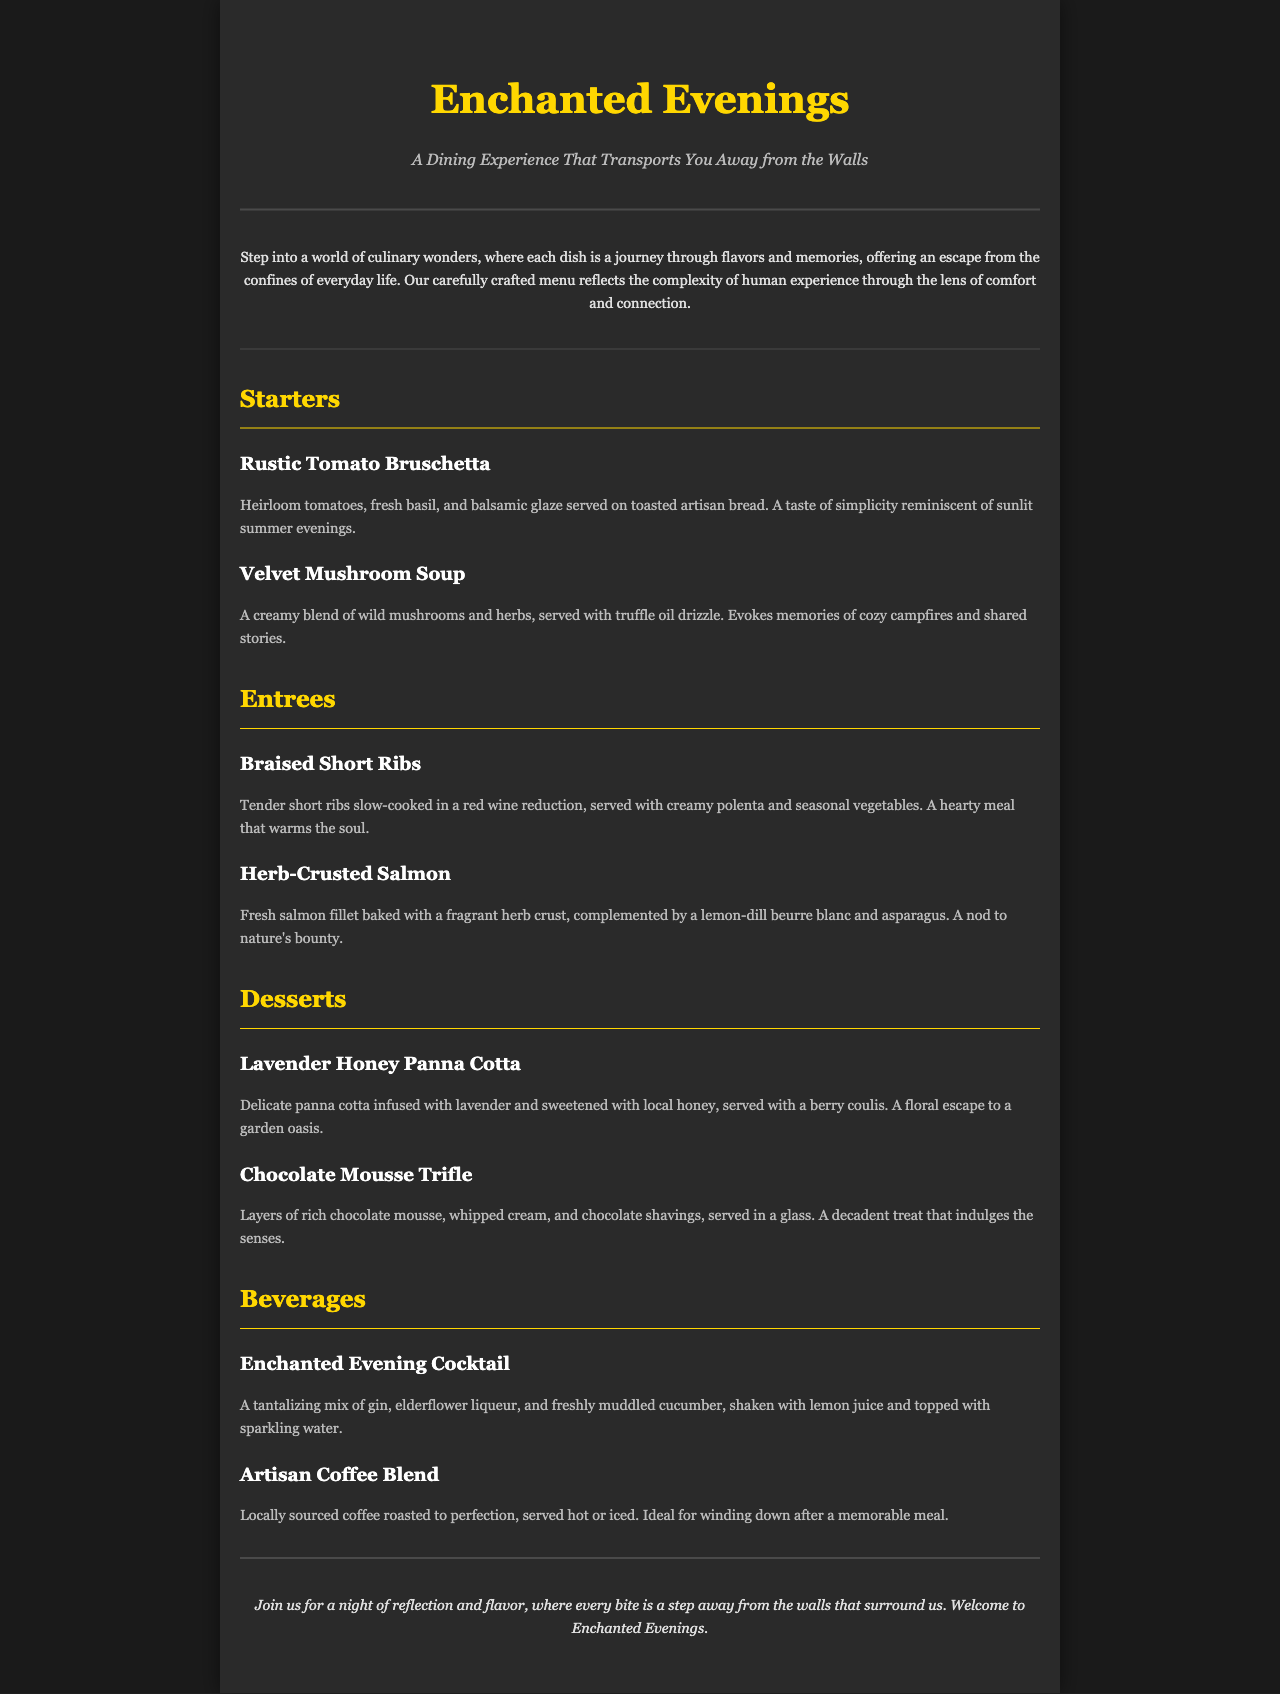what is the name of the dining experience? The title of the dining experience is mentioned at the top of the document as "Enchanted Evenings."
Answer: Enchanted Evenings how many sections are in the menu? The menu contains four sections: Starters, Entrees, Desserts, and Beverages.
Answer: Four what is the first starter listed on the menu? The first starter listed in the Starters section is "Rustic Tomato Bruschetta."
Answer: Rustic Tomato Bruschetta which dessert includes lavender? The dessert that includes lavender is "Lavender Honey Panna Cotta."
Answer: Lavender Honey Panna Cotta what kind of fish is served in the entrees? The type of fish served in the entrees is salmon, specifically "Herb-Crusted Salmon."
Answer: Salmon what flavor profile does the Enchanted Evening Cocktail feature? The cocktail features a mix of gin, elderflower liqueur, and cucumber, with a refreshing aspect from the lemon juice and sparkling water.
Answer: Gin, elderflower, cucumber which beverage is ideal for winding down after a meal? The beverage described as ideal for winding down after a meal is "Artisan Coffee Blend."
Answer: Artisan Coffee Blend which section includes the Chocolate Mousse Trifle? The Chocolate Mousse Trifle is included in the Desserts section of the menu.
Answer: Desserts what is the primary theme of the introduction? The introduction emphasizes stepping into a world of culinary wonders and escaping everyday life.
Answer: Culinary wonders and escape 